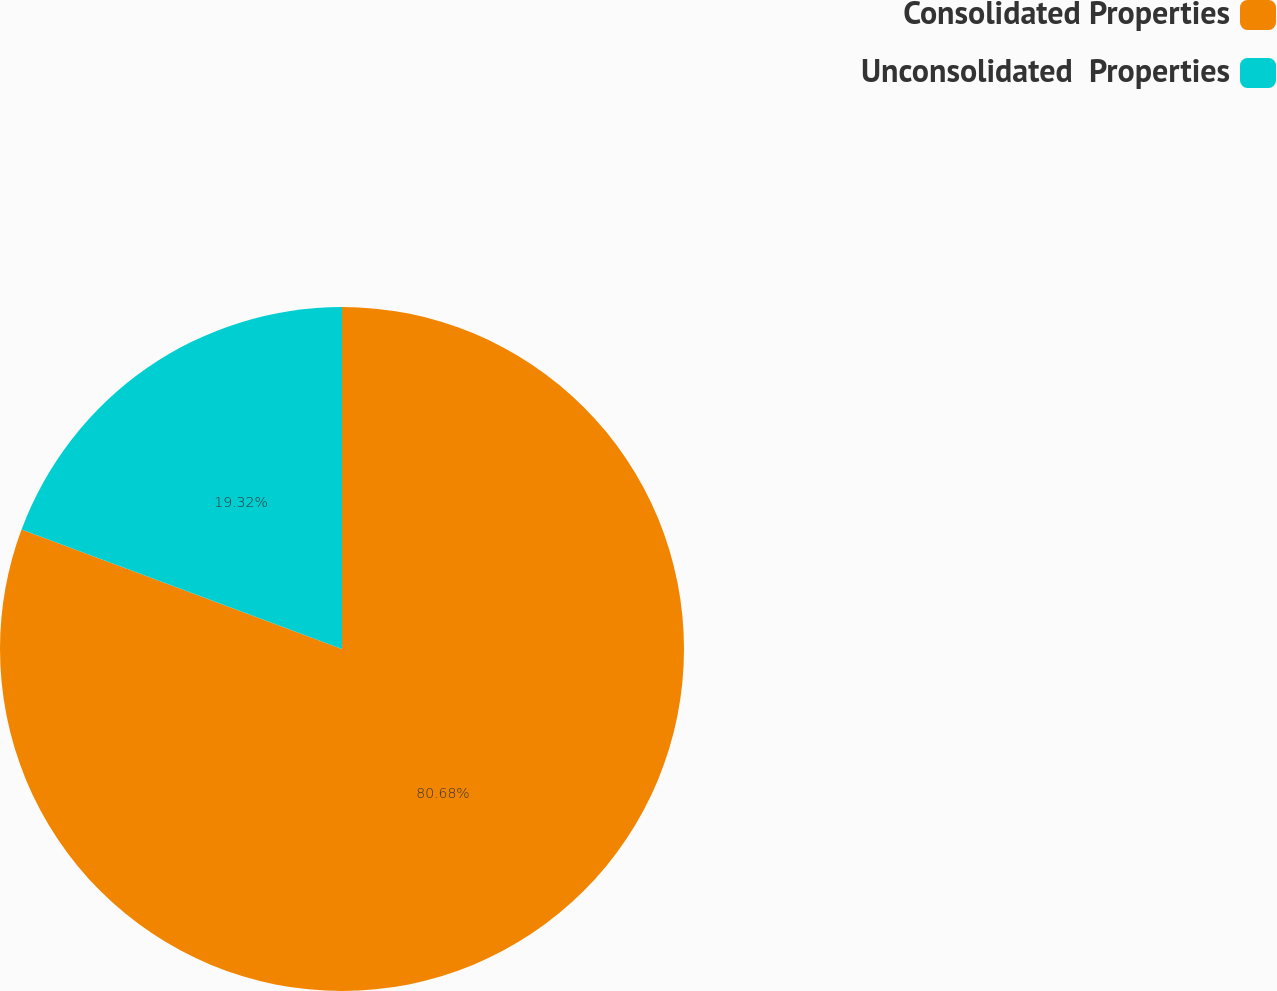Convert chart to OTSL. <chart><loc_0><loc_0><loc_500><loc_500><pie_chart><fcel>Consolidated Properties<fcel>Unconsolidated  Properties<nl><fcel>80.68%<fcel>19.32%<nl></chart> 